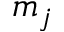<formula> <loc_0><loc_0><loc_500><loc_500>m _ { j }</formula> 